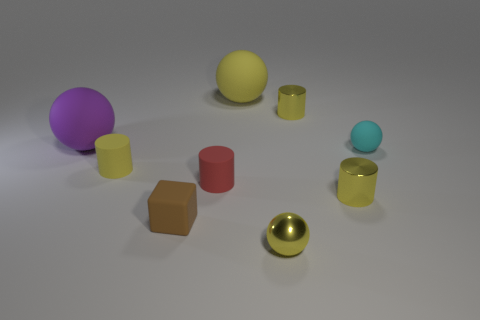There is a brown rubber thing; is it the same shape as the tiny yellow object that is left of the small red matte thing?
Offer a very short reply. No. What is the color of the metallic thing that is in front of the yellow shiny cylinder on the right side of the tiny thing that is behind the tiny cyan rubber ball?
Offer a terse response. Yellow. There is a tiny yellow rubber cylinder; are there any yellow matte spheres to the left of it?
Make the answer very short. No. The other sphere that is the same color as the shiny ball is what size?
Offer a terse response. Large. Is there a big cube that has the same material as the large purple sphere?
Your answer should be very brief. No. The matte block has what color?
Your answer should be compact. Brown. Do the tiny yellow metallic object behind the small cyan sphere and the large purple object have the same shape?
Offer a very short reply. No. The tiny metallic object that is behind the rubber object that is right of the yellow metallic cylinder that is behind the purple matte object is what shape?
Keep it short and to the point. Cylinder. What is the material of the tiny yellow thing to the left of the rubber cube?
Provide a short and direct response. Rubber. What is the color of the block that is the same size as the cyan rubber ball?
Ensure brevity in your answer.  Brown. 